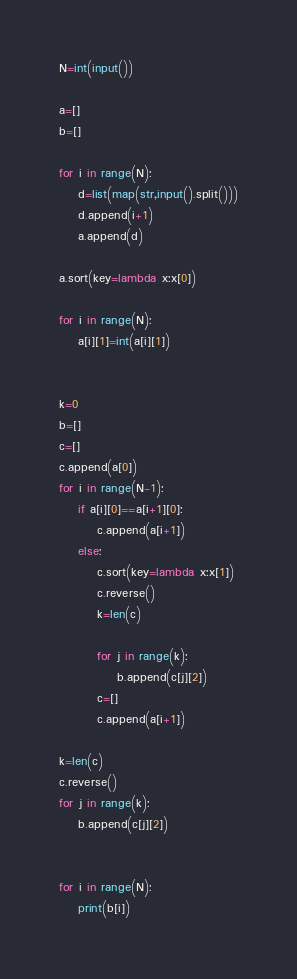<code> <loc_0><loc_0><loc_500><loc_500><_Python_>N=int(input())

a=[]
b=[]

for i in range(N):
    d=list(map(str,input().split()))
    d.append(i+1)
    a.append(d)

a.sort(key=lambda x:x[0])

for i in range(N):
    a[i][1]=int(a[i][1])


k=0
b=[]
c=[]
c.append(a[0])
for i in range(N-1):
    if a[i][0]==a[i+1][0]:
        c.append(a[i+1])
    else:
        c.sort(key=lambda x:x[1])
        c.reverse()
        k=len(c)

        for j in range(k):
            b.append(c[j][2])
        c=[]
        c.append(a[i+1])

k=len(c)
c.reverse()
for j in range(k):
    b.append(c[j][2])


for i in range(N):
    print(b[i])
</code> 